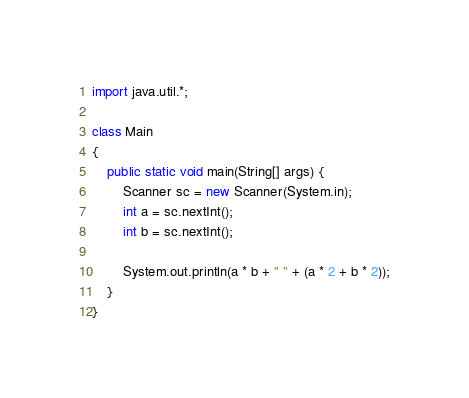Convert code to text. <code><loc_0><loc_0><loc_500><loc_500><_Java_>import java.util.*;

class Main
{
    public static void main(String[] args) {
        Scanner sc = new Scanner(System.in);
        int a = sc.nextInt();
        int b = sc.nextInt();

        System.out.println(a * b + " " + (a * 2 + b * 2));
    }
}</code> 